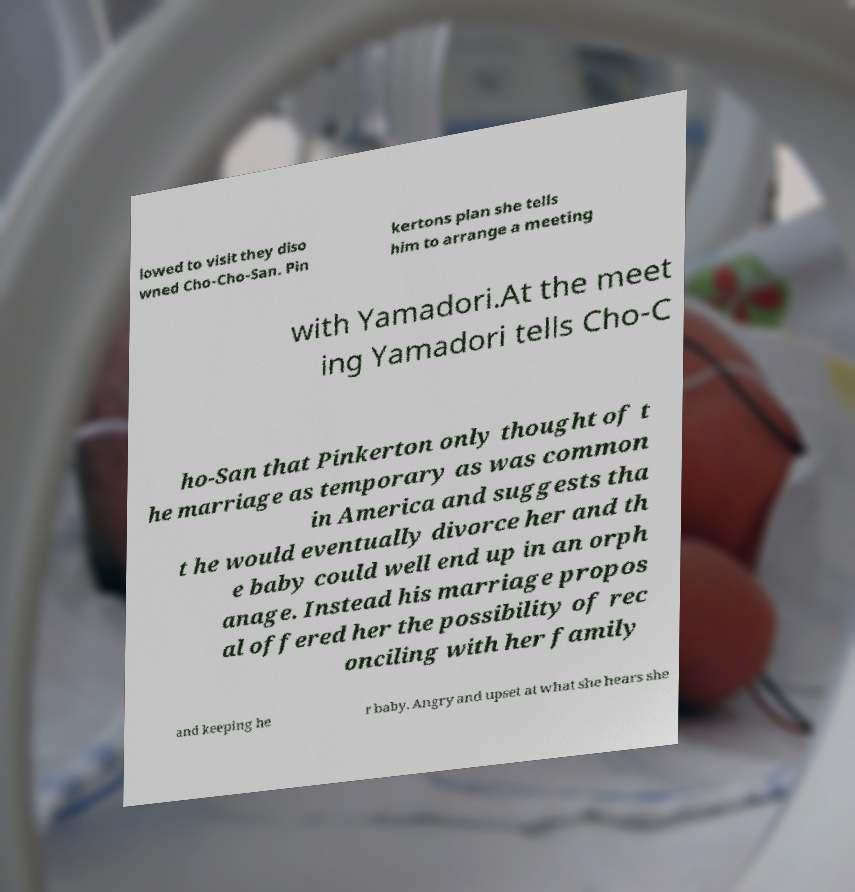What messages or text are displayed in this image? I need them in a readable, typed format. lowed to visit they diso wned Cho-Cho-San. Pin kertons plan she tells him to arrange a meeting with Yamadori.At the meet ing Yamadori tells Cho-C ho-San that Pinkerton only thought of t he marriage as temporary as was common in America and suggests tha t he would eventually divorce her and th e baby could well end up in an orph anage. Instead his marriage propos al offered her the possibility of rec onciling with her family and keeping he r baby. Angry and upset at what she hears she 